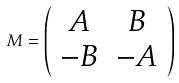<formula> <loc_0><loc_0><loc_500><loc_500>M = \left ( \begin{array} { c c } A & B \\ - B & - A \end{array} \right )</formula> 